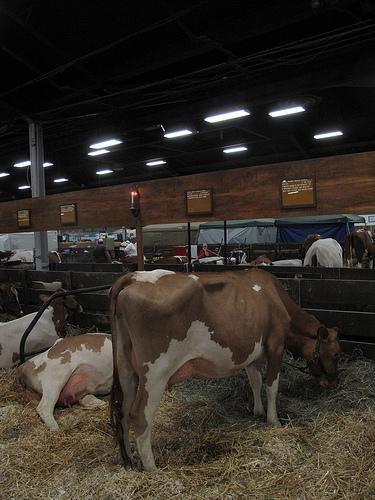How many cows are laying down?
Give a very brief answer. 2. 